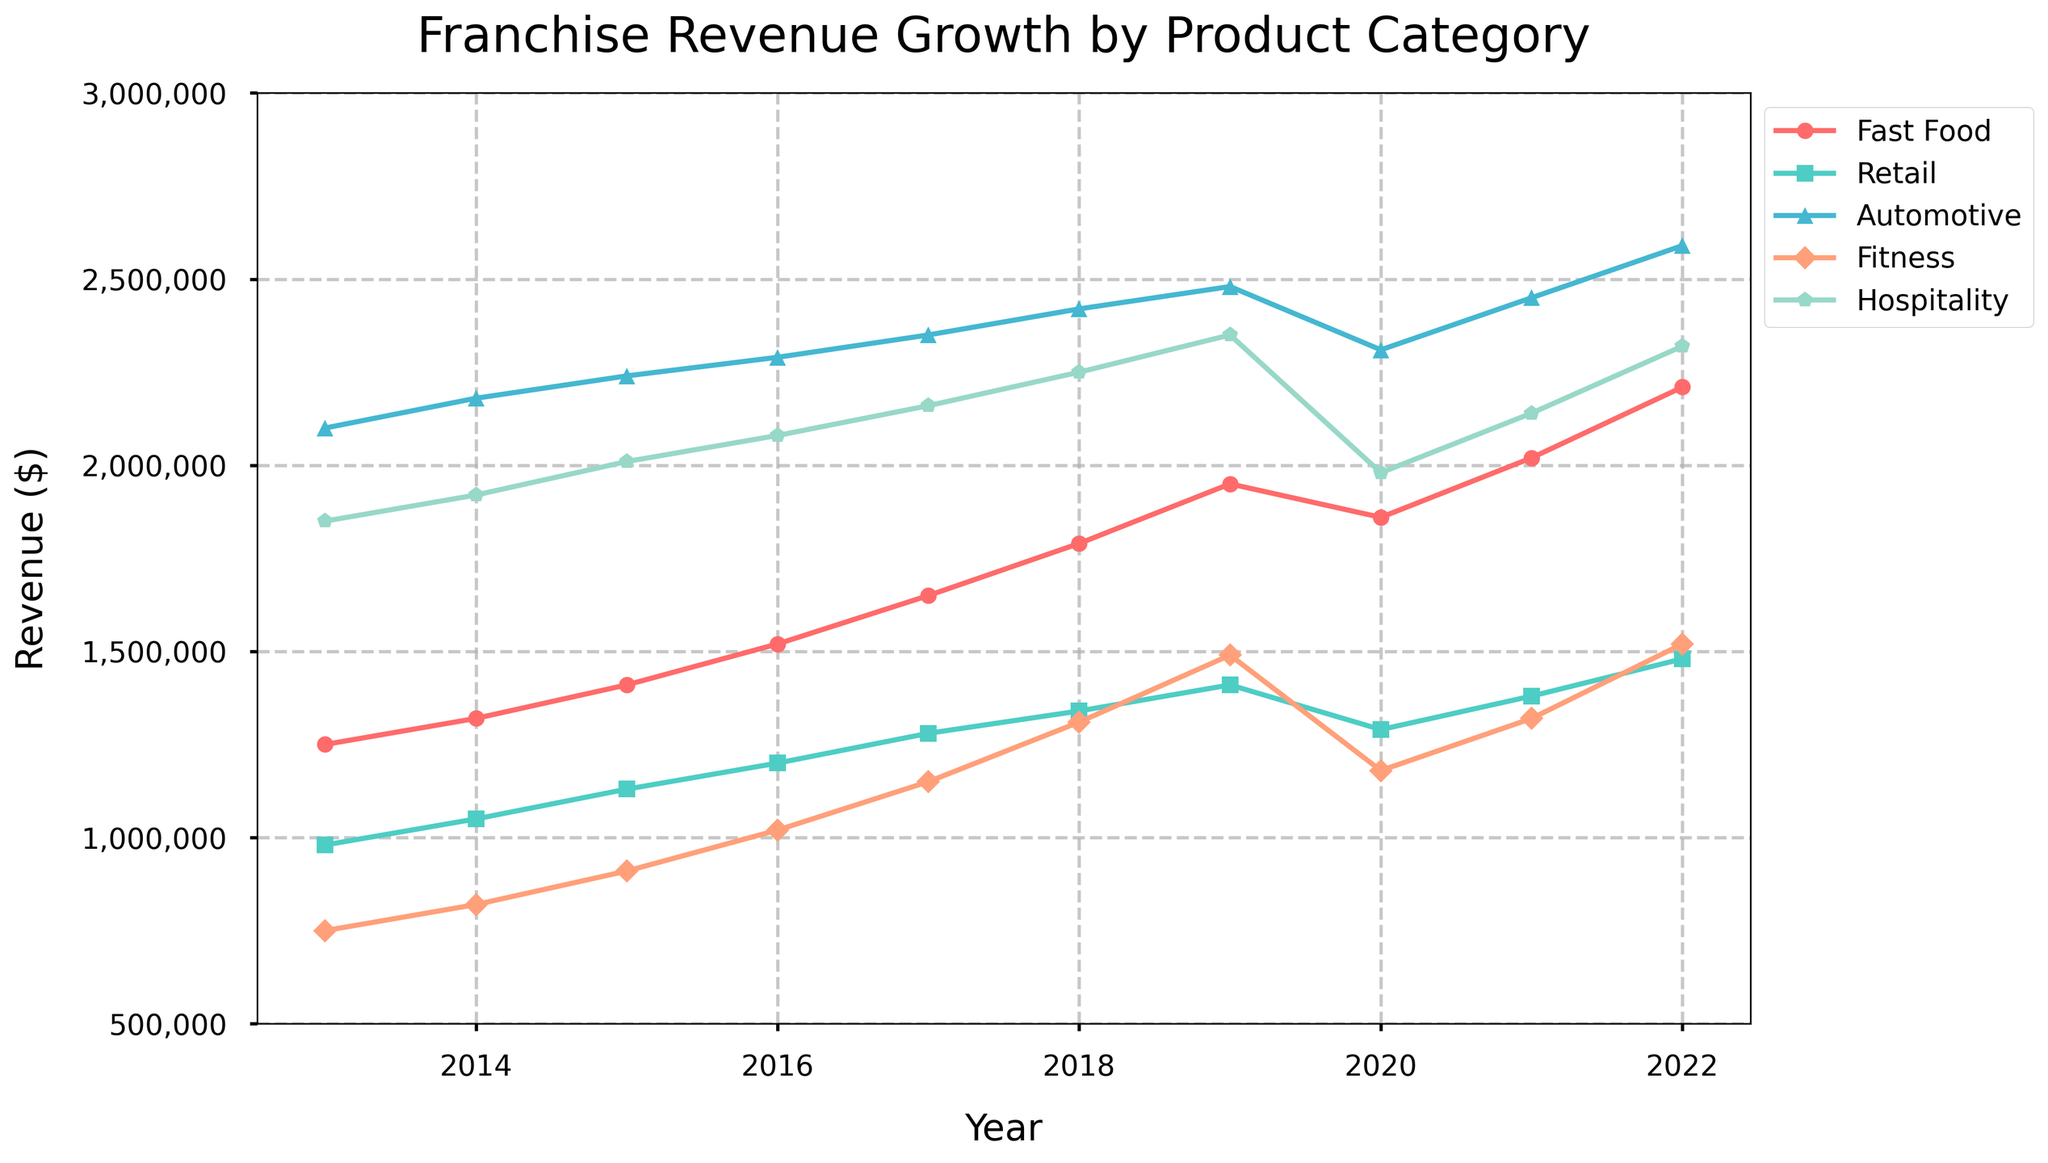What was the revenue growth for the Fast Food category from 2013 to 2022? To find the revenue growth for the Fast Food category from 2013 to 2022, subtract the revenue in 2013 from the revenue in 2022. Thus, 2,210,000 - 1,250,000 = 960,000.
Answer: 960,000 Which product category experienced the highest revenue in 2020? Observe the highest point in 2020 by comparing the revenue values for all categories in that year. The Automotive category shows the highest value at 2,310,000.
Answer: Automotive Compare the revenue growth between Fast Food and Fitness categories from 2019 to 2022. Which saw a greater absolute increase? Calculate the revenue differences for both categories from 2019 to 2022. Fast Food: 2,210,000 - 1,950,000 = 260,000. Fitness: 1,520,000 - 1,490,000 = 30,000. Fast Food saw a greater increase.
Answer: Fast Food What is the total revenue for the Retail category over the first three years (2013 - 2015)? Sum up the yearly revenues for the Retail category from 2013 to 2015: 980,000 + 1,050,000 + 1,130,000 = 3,160,000.
Answer: 3,160,000 Which year did the Fitness category surpass 1,000,000 in revenue? Look for the first year that the Fitness category's revenue exceeded 1,000,000. In 2016, the revenue was 1,020,000, surpassing 1,000,000.
Answer: 2016 Did any category experience a revenue decline from 2019 to 2020? Compare revenues for all categories between 2019 and 2020. The Fast Food, Retail, Fitness, and Hospitality categories experienced declines.
Answer: Yes What is the average annual revenue for the Hospitality category from 2013 to 2022? Sum up the annual revenues for the Hospitality category and divide by the number of years (10). Total revenue is 1,850,000 + 1,920,000 + 2,010,000 + 2,080,000 + 2,160,000 + 2,250,000 + 2,350,000 + 1,980,000 + 2,140,000 + 2,320,000 = 20,060,000. Average revenue: 20,060,000 / 10 = 2,006,000.
Answer: 2,006,000 Which year saw the Fast Food category experiencing the smallest growth compared to the previous year? Calculate year-over-year differences for the Fast Food category and identify the smallest positive difference: 2020 (1,860,000 - 1,950,000 = -90,000). In terms of growth: 2019 (1,950,000 - 1,790,000 = 160,000).
Answer: 2020 What was the combined revenue of all categories in 2021? Sum up the revenue of all categories in 2021. Fast Food: 2,020,000, Retail: 1,380,000, Automotive: 2,450,000, Fitness: 1,320,000, Hospitality: 2,140,000. Combined revenue: 2,020,000 + 1,380,000 + 2,450,000 + 1,320,000 + 2,140,000 = 9,310,000.
Answer: 9,310,000 